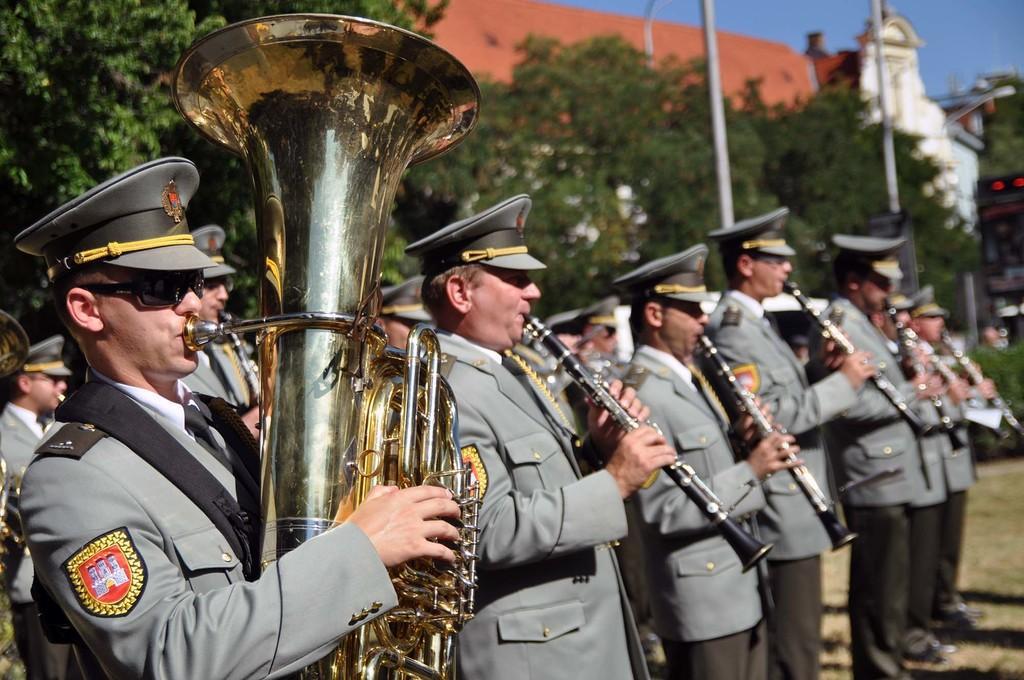Can you describe this image briefly? In this image there are group of people standing and holding the clarinets, tuba, and in the background there are trees, poles, building,sky. 